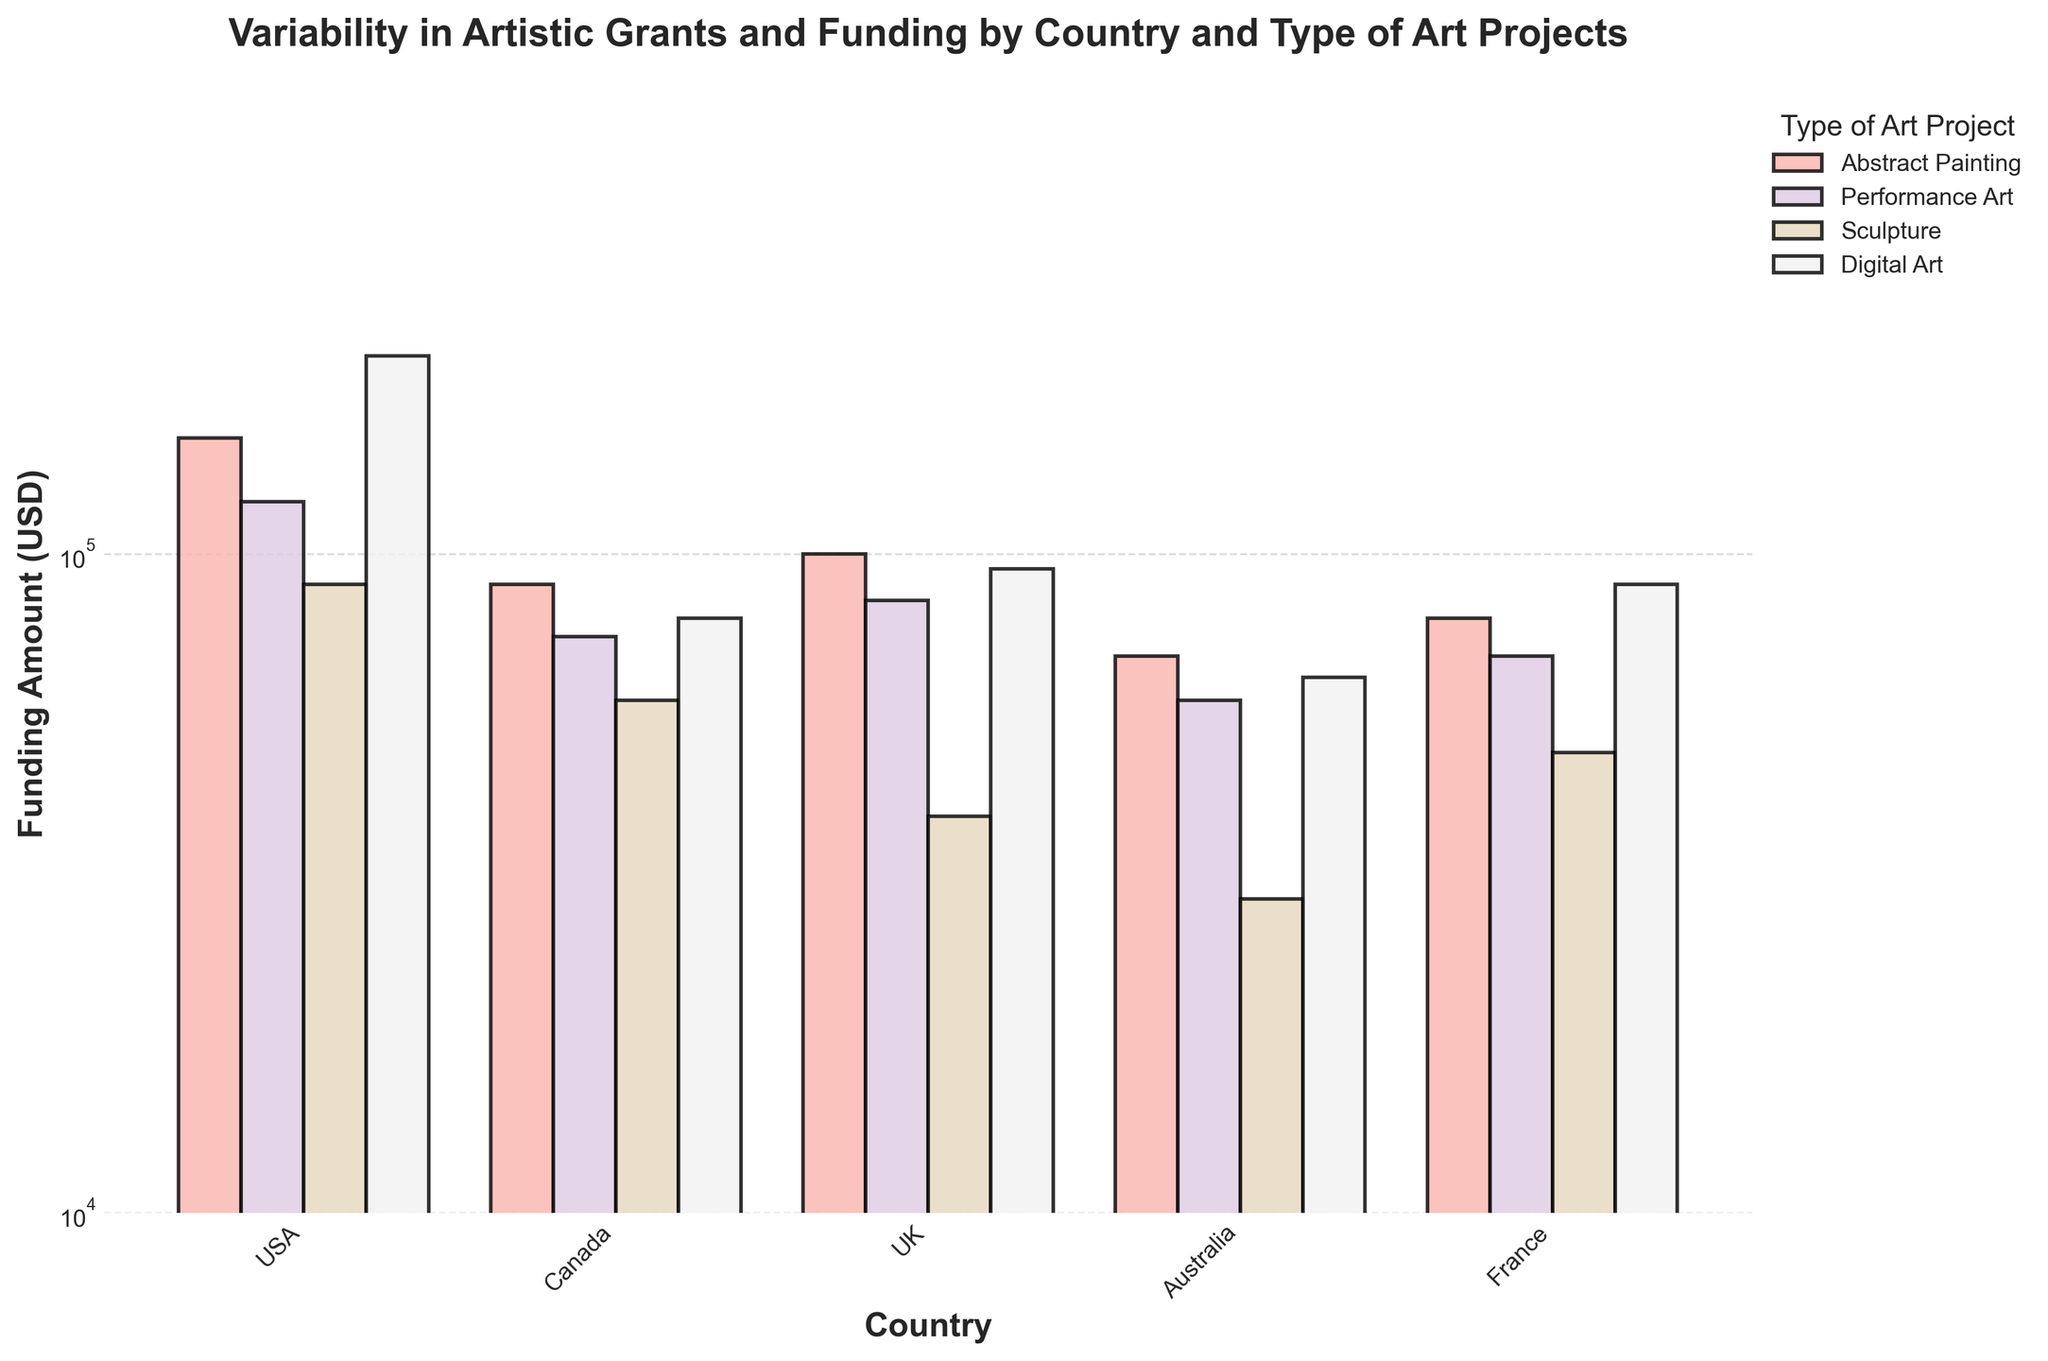What's the title of the plot? The title of the plot is written at the top center of the figure. It reads "Variability in Artistic Grants and Funding by Country and Type of Art Projects".
Answer: Variability in Artistic Grants and Funding by Country and Type of Art Projects What is the funding amount for Digital Art in the USA? By locating the bar for Digital Art in the USA on the plot, we can see that the height of the bar aligns with a value of 200,000 USD. The y-axis is labeled with funding amounts, allowing us to read this directly.
Answer: 200000 USD How many countries are represented in the plot? Referring to the x-axis labels, which lists all the countries depicted in the plot, we can count 5 countries: USA, Canada, UK, Australia, and France.
Answer: 5 Which type of art project received the lowest funding in the UK? By examining the bars corresponding to the UK, we notice that the bar representing Sculpture has the smallest height, indicating the lowest funding amount.
Answer: Sculpture Compare the funding amounts for Abstract Painting between the USA and Australia. Which country provides more funding for this type of project? We look at the bars representing Abstract Painting for both the USA and Australia. The bar in the USA is higher than the one in Australia, indicating the USA provides more funding for Abstract Painting.
Answer: USA What is the difference in funding between Performance Art in Canada and Sculpture in Australia? We locate the bars for Performance Art in Canada and Sculpture in Australia. Performance Art in Canada is funded at 75,000 USD, while Sculpture in Australia is funded at 30,000 USD. The difference is calculated as 75,000 - 30,000 = 45,000 USD.
Answer: 45000 USD Identify the country that has the most consistent funding levels across all types of art projects. By comparing the heights of the bars for each country, France's bars are most similar in height, indicating more consistent funding levels across different types of art projects.
Answer: France What is the average funding amount for Digital Art across all countries? We find the funding amounts for Digital Art in all countries: USA (200,000), Canada (80,000), UK (95,000), Australia (65,000), and France (90,000). Adding these amounts: 200,000 + 80,000 + 95,000 + 65,000 + 90,000 = 530,000. Dividing by 5 (the number of countries) gives 530,000/5 = 106,000 USD.
Answer: 106000 USD By how much is the funding for Sculpture in the USA higher than in the UK? The funding for Sculpture is 90,000 USD in the USA and 40,000 USD in the UK. The difference is calculated as 90,000 - 40,000 = 50,000 USD.
Answer: 50000 USD Why might a log scale be used in the y-axis of this plot? A log scale is useful when there is a large range of funding amounts, as it allows for better visualization of smaller funding differences between projects that are closer in value and contrasts between higher and lower funding amounts more clearly.
Answer: To visualize a large range of funding amounts effectively 